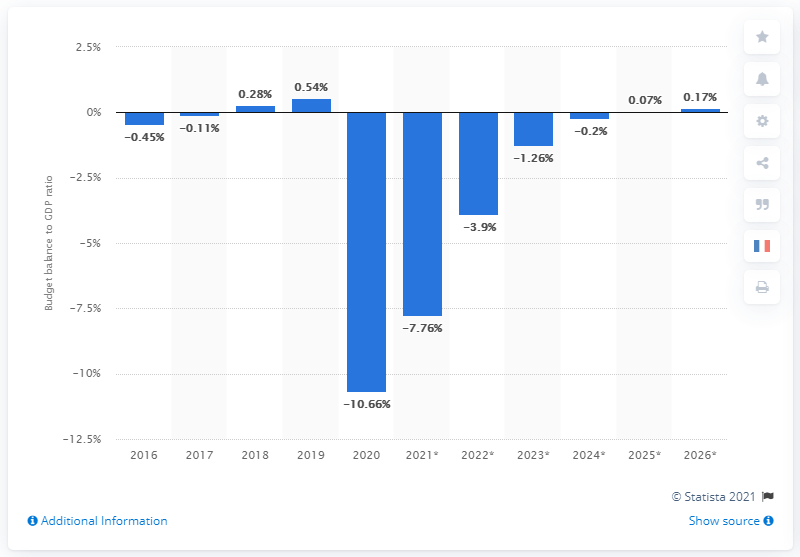Identify some key points in this picture. In 2020, the budget balance in Canada was balanced. 